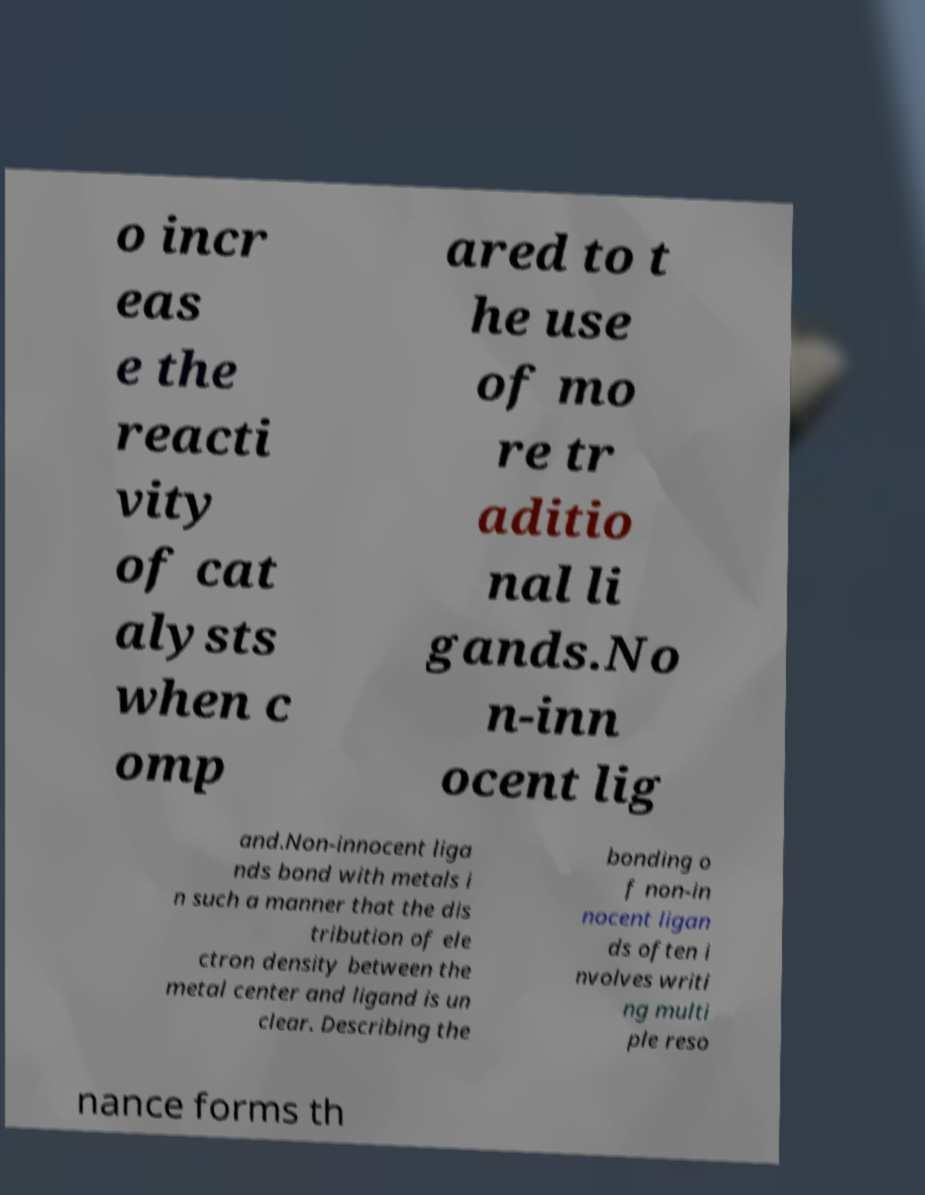For documentation purposes, I need the text within this image transcribed. Could you provide that? o incr eas e the reacti vity of cat alysts when c omp ared to t he use of mo re tr aditio nal li gands.No n-inn ocent lig and.Non-innocent liga nds bond with metals i n such a manner that the dis tribution of ele ctron density between the metal center and ligand is un clear. Describing the bonding o f non-in nocent ligan ds often i nvolves writi ng multi ple reso nance forms th 